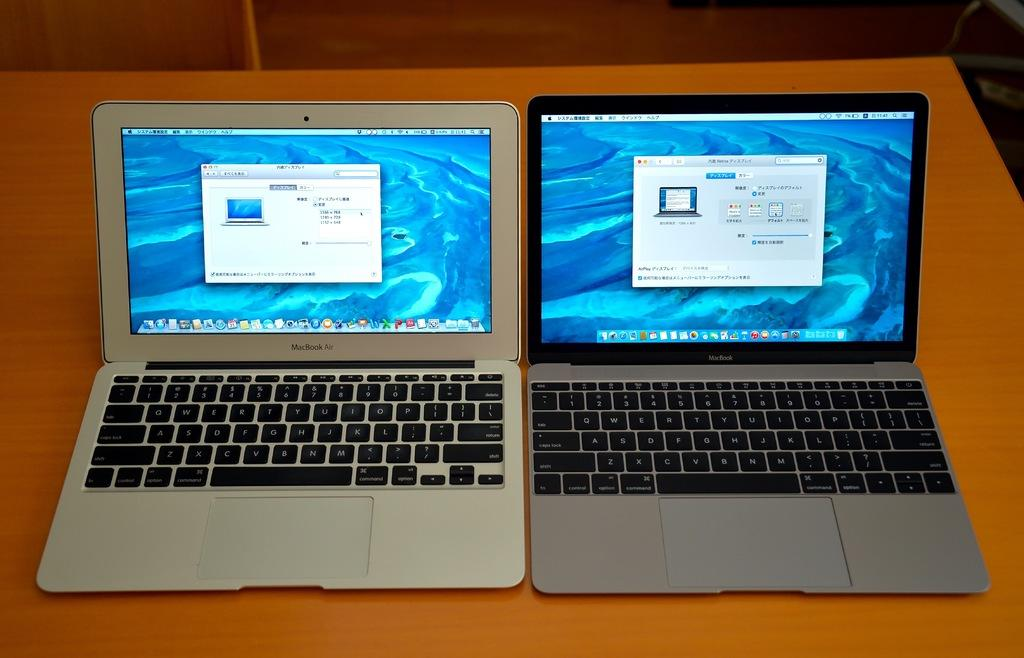<image>
Give a short and clear explanation of the subsequent image. Two laptop computers on a brown table are side by side and are made by Macbook. 